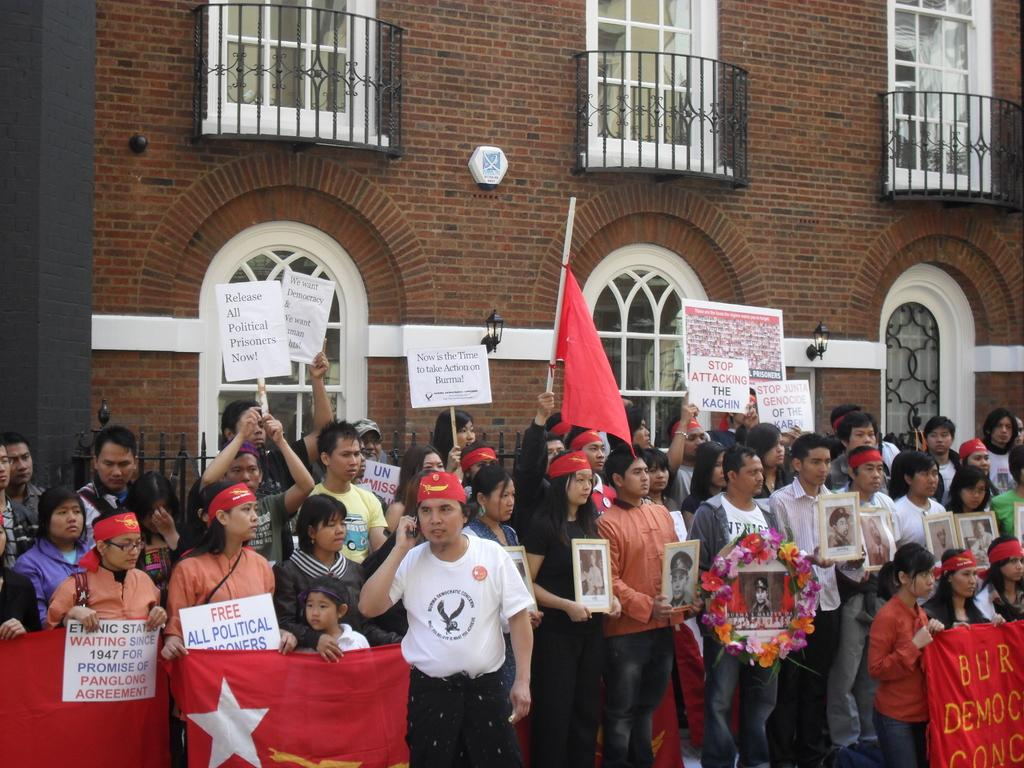What are the people in the image doing? The people in the image are standing. What are some of the people holding? Some people are holding banners. What can be seen in the image that represents a country or organization? There is a red color flag in the image. What is visible in the background of the image? There is a building in the background of the image. What type of windows does the building have? The building has glass windows. Can you see a zebra or an owl in the image? No, there is no zebra or owl present in the image. Is there a carriage visible in the image? No, there is no carriage present in the image. 